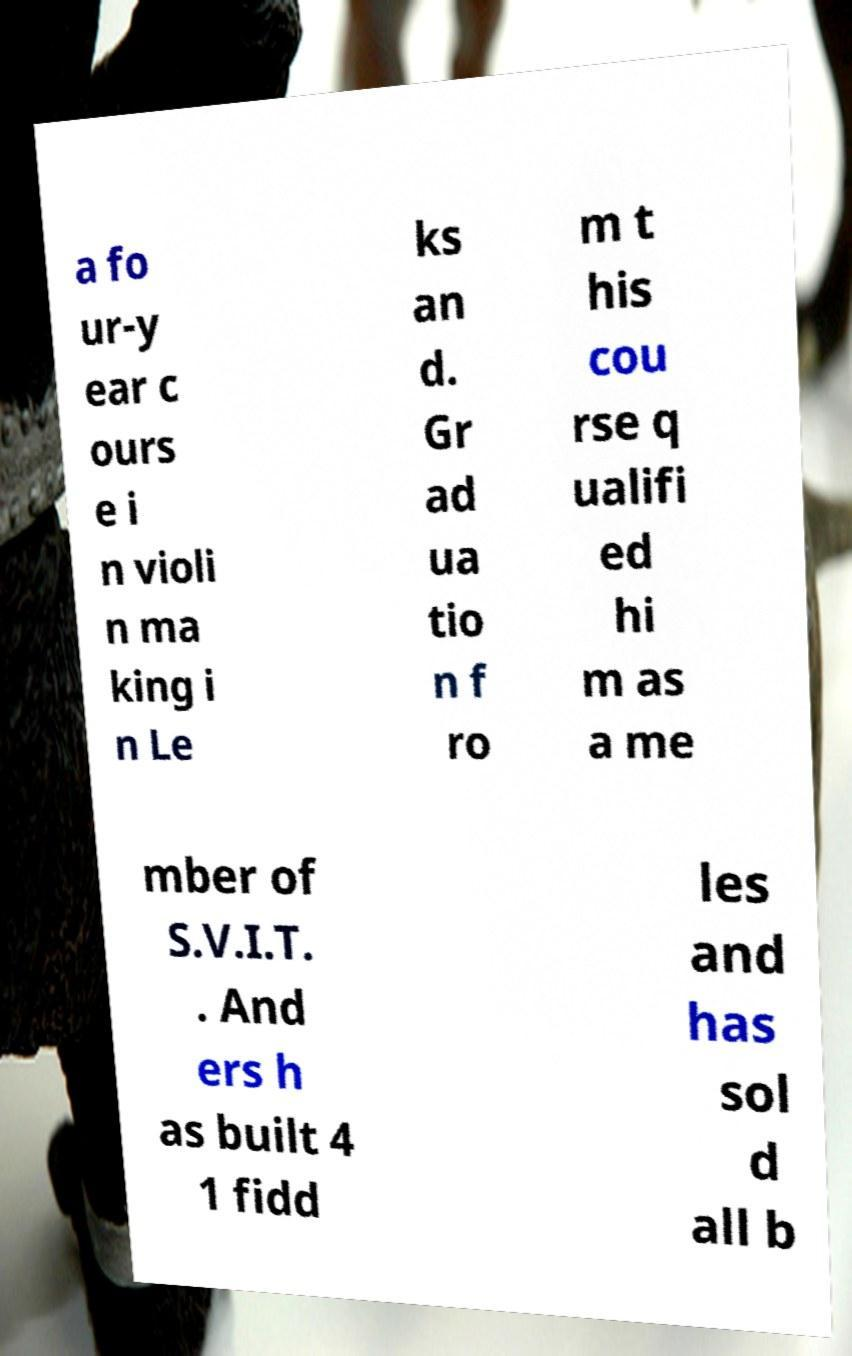Could you extract and type out the text from this image? a fo ur-y ear c ours e i n violi n ma king i n Le ks an d. Gr ad ua tio n f ro m t his cou rse q ualifi ed hi m as a me mber of S.V.I.T. . And ers h as built 4 1 fidd les and has sol d all b 